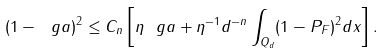<formula> <loc_0><loc_0><loc_500><loc_500>( 1 - \ g a ) ^ { 2 } \leq C _ { n } \left [ \eta \ g a + \eta ^ { - 1 } d ^ { - n } \int _ { Q _ { d } } ( 1 - P _ { F } ) ^ { 2 } d x \right ] .</formula> 